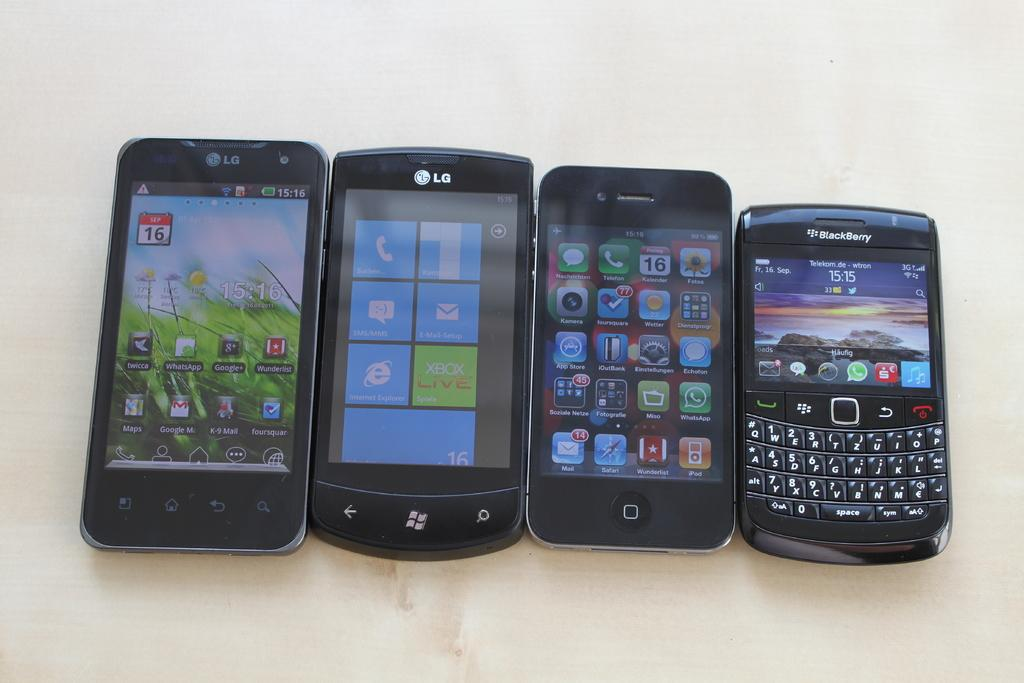<image>
Relay a brief, clear account of the picture shown. A row of LG and Blackberry electronic devices arranged in order of descending size. 